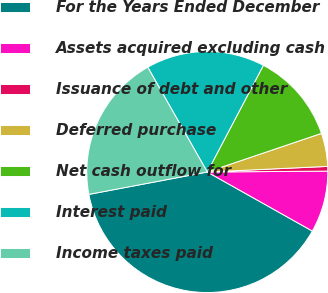Convert chart. <chart><loc_0><loc_0><loc_500><loc_500><pie_chart><fcel>For the Years Ended December<fcel>Assets acquired excluding cash<fcel>Issuance of debt and other<fcel>Deferred purchase<fcel>Net cash outflow for<fcel>Interest paid<fcel>Income taxes paid<nl><fcel>38.88%<fcel>8.27%<fcel>0.62%<fcel>4.45%<fcel>12.1%<fcel>15.93%<fcel>19.75%<nl></chart> 